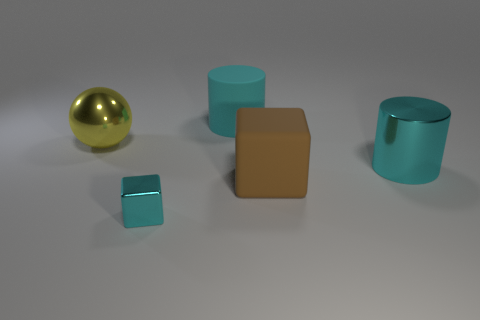There is a cyan metallic thing that is the same size as the cyan matte object; what shape is it?
Your answer should be very brief. Cylinder. There is a big thing that is the same color as the metal cylinder; what is its material?
Offer a terse response. Rubber. There is a cyan block; are there any large yellow things in front of it?
Ensure brevity in your answer.  No. Is there a big cyan matte object of the same shape as the large yellow shiny object?
Make the answer very short. No. There is a big metallic object that is on the right side of the rubber cylinder; is its shape the same as the cyan rubber thing that is behind the tiny cyan thing?
Provide a short and direct response. Yes. Are there any cyan cylinders of the same size as the ball?
Your response must be concise. Yes. Are there an equal number of large brown rubber cubes that are in front of the cyan rubber cylinder and brown rubber cubes right of the metal cylinder?
Give a very brief answer. No. Is the large thing left of the tiny cyan metal cube made of the same material as the big cyan cylinder that is right of the big brown matte block?
Your answer should be compact. Yes. What is the material of the tiny block?
Offer a very short reply. Metal. How many other objects are the same color as the large rubber cylinder?
Your response must be concise. 2. 